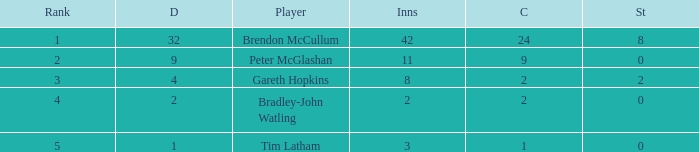How many innings had a total of 2 catches and 0 stumpings? 1.0. 